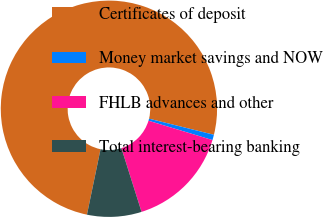<chart> <loc_0><loc_0><loc_500><loc_500><pie_chart><fcel>Certificates of deposit<fcel>Money market savings and NOW<fcel>FHLB advances and other<fcel>Total interest-bearing banking<nl><fcel>75.61%<fcel>0.81%<fcel>15.45%<fcel>8.13%<nl></chart> 